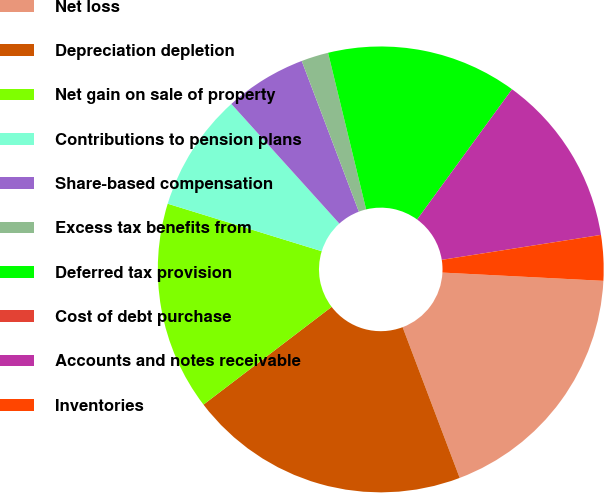Convert chart to OTSL. <chart><loc_0><loc_0><loc_500><loc_500><pie_chart><fcel>Net loss<fcel>Depreciation depletion<fcel>Net gain on sale of property<fcel>Contributions to pension plans<fcel>Share-based compensation<fcel>Excess tax benefits from<fcel>Deferred tax provision<fcel>Cost of debt purchase<fcel>Accounts and notes receivable<fcel>Inventories<nl><fcel>18.42%<fcel>20.39%<fcel>15.13%<fcel>8.55%<fcel>5.92%<fcel>1.97%<fcel>13.82%<fcel>0.0%<fcel>12.5%<fcel>3.29%<nl></chart> 